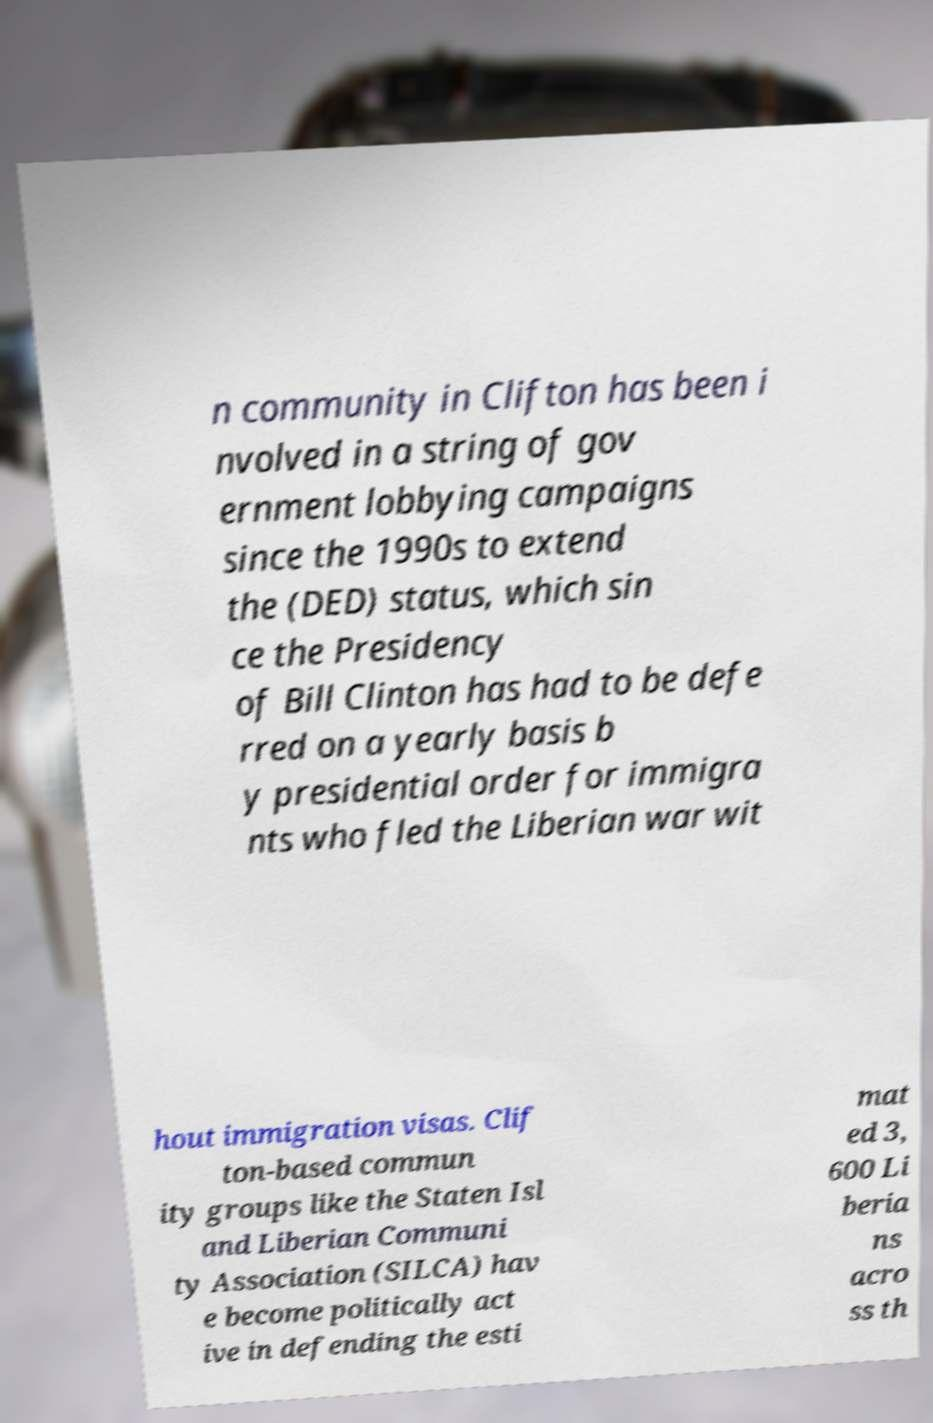Can you accurately transcribe the text from the provided image for me? n community in Clifton has been i nvolved in a string of gov ernment lobbying campaigns since the 1990s to extend the (DED) status, which sin ce the Presidency of Bill Clinton has had to be defe rred on a yearly basis b y presidential order for immigra nts who fled the Liberian war wit hout immigration visas. Clif ton-based commun ity groups like the Staten Isl and Liberian Communi ty Association (SILCA) hav e become politically act ive in defending the esti mat ed 3, 600 Li beria ns acro ss th 